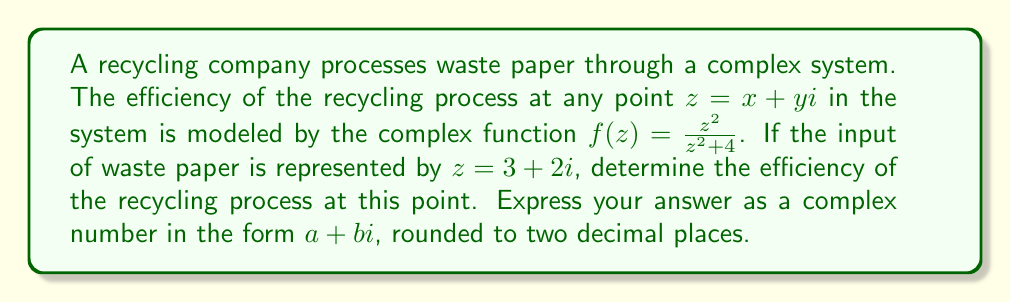Teach me how to tackle this problem. To solve this problem, we need to evaluate the complex function $f(z)$ at the point $z = 3 + 2i$. Let's break this down step-by-step:

1) We have $f(z) = \frac{z^2}{z^2 + 4}$ and $z = 3 + 2i$

2) First, let's calculate $z^2$:
   $z^2 = (3 + 2i)^2 = 9 + 12i + 4i^2 = 9 + 12i - 4 = 5 + 12i$

3) Now, we can evaluate the numerator and denominator of $f(z)$:
   Numerator: $z^2 = 5 + 12i$
   Denominator: $z^2 + 4 = (5 + 12i) + 4 = 9 + 12i$

4) So, we have:
   $f(3 + 2i) = \frac{5 + 12i}{9 + 12i}$

5) To divide complex numbers, we multiply both numerator and denominator by the complex conjugate of the denominator:
   $f(3 + 2i) = \frac{(5 + 12i)(9 - 12i)}{(9 + 12i)(9 - 12i)}$

6) Simplify the numerator:
   $(5 + 12i)(9 - 12i) = 45 - 60i + 108i - 144i^2 = 45 + 48i + 144 = 189 + 48i$

7) Simplify the denominator:
   $(9 + 12i)(9 - 12i) = 81 - 144i^2 = 81 + 144 = 225$

8) Therefore:
   $f(3 + 2i) = \frac{189 + 48i}{225} = \frac{189}{225} + \frac{48}{225}i$

9) Simplifying and rounding to two decimal places:
   $f(3 + 2i) \approx 0.84 + 0.21i$

This complex number represents the efficiency of the recycling process at the given input point. The real part (0.84) represents the actual recycling efficiency, while the imaginary part (0.21) might represent some secondary aspect of the process, such as energy consumption or byproduct generation.
Answer: $0.84 + 0.21i$ 